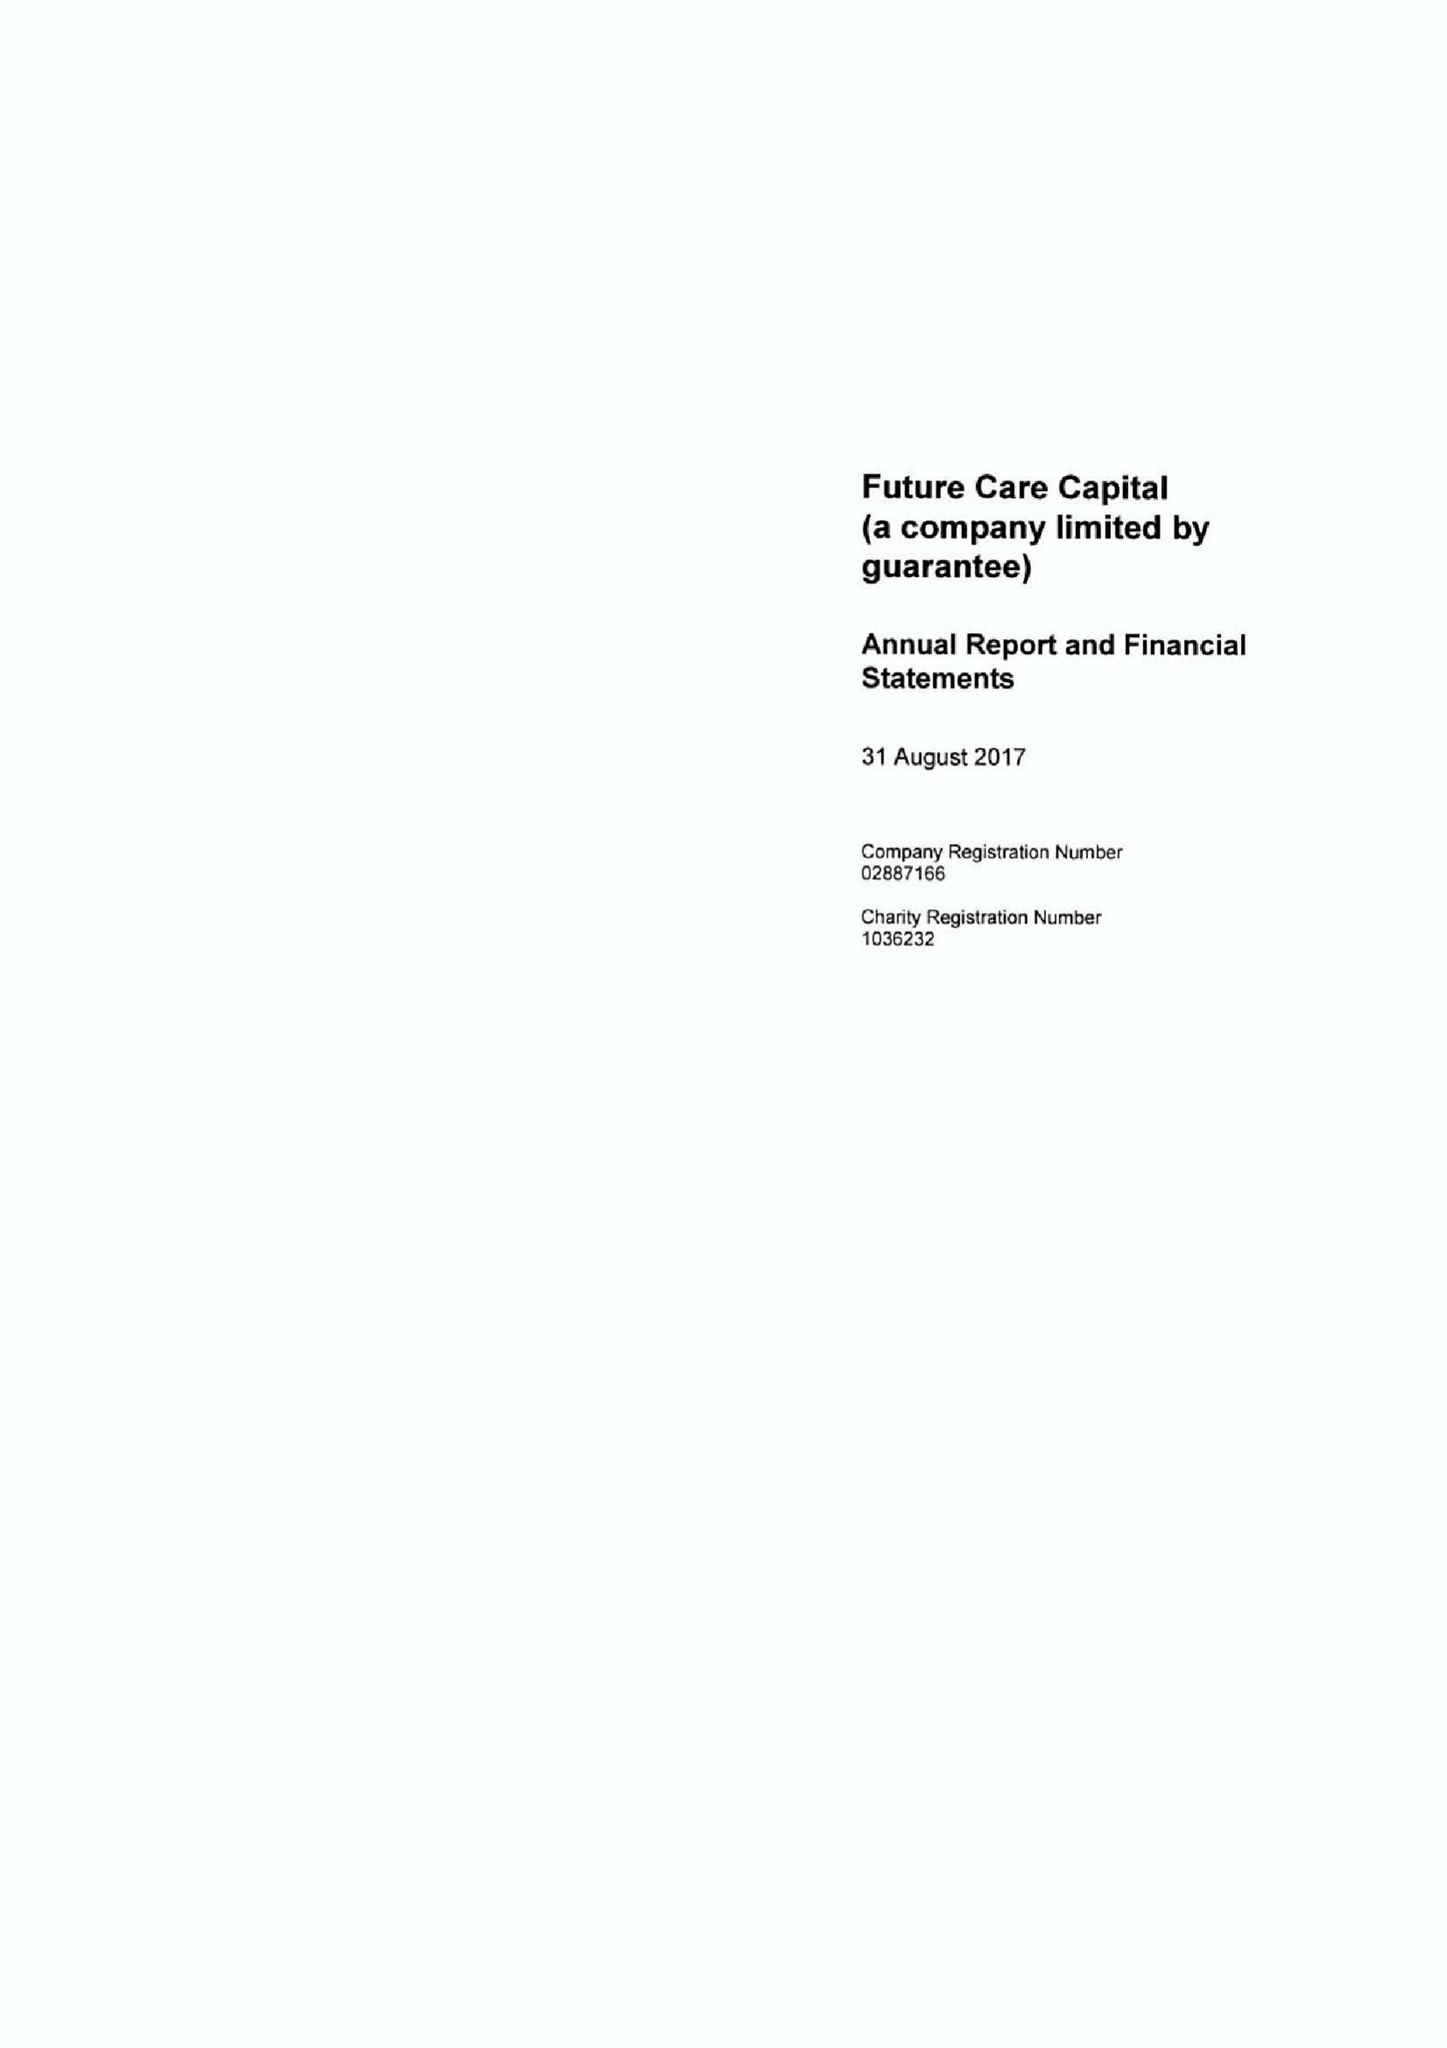What is the value for the address__post_town?
Answer the question using a single word or phrase. LONDON 